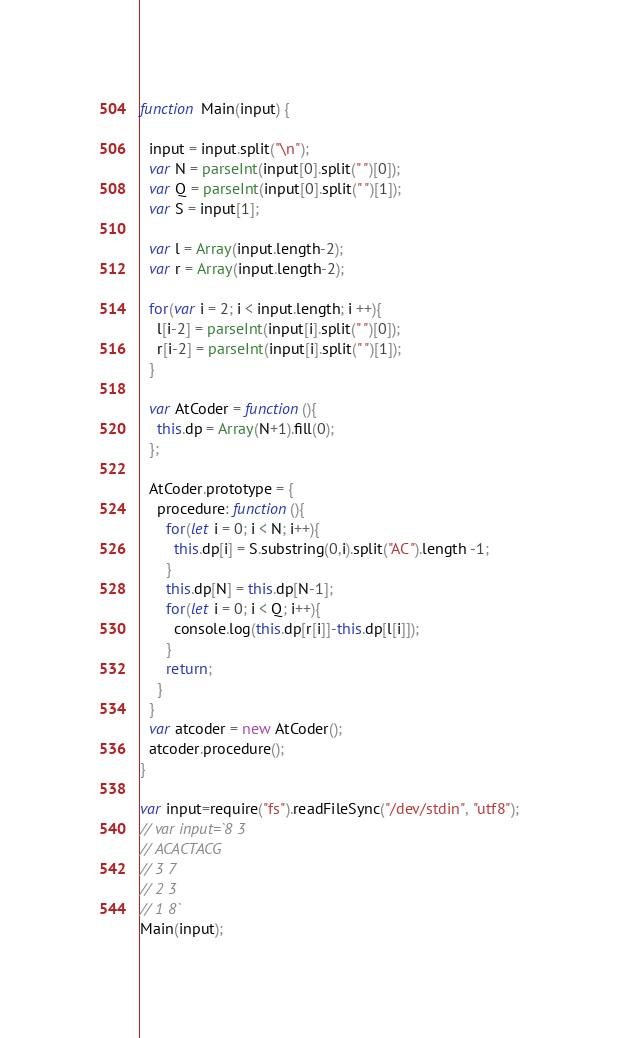<code> <loc_0><loc_0><loc_500><loc_500><_TypeScript_>function Main(input) {

  input = input.split("\n");
  var N = parseInt(input[0].split(" ")[0]);
  var Q = parseInt(input[0].split(" ")[1]);
  var S = input[1];

  var l = Array(input.length-2);
  var r = Array(input.length-2);

  for(var i = 2; i < input.length; i ++){
    l[i-2] = parseInt(input[i].split(" ")[0]);
    r[i-2] = parseInt(input[i].split(" ")[1]);
  }

  var AtCoder = function(){
    this.dp = Array(N+1).fill(0);
  };

  AtCoder.prototype = {
    procedure: function(){
      for(let i = 0; i < N; i++){
        this.dp[i] = S.substring(0,i).split("AC").length -1;
      }
      this.dp[N] = this.dp[N-1];
      for(let i = 0; i < Q; i++){
        console.log(this.dp[r[i]]-this.dp[l[i]]);
      }
      return;
    }
  }
  var atcoder = new AtCoder();
  atcoder.procedure();
}

var input=require("fs").readFileSync("/dev/stdin", "utf8");
// var input=`8 3
// ACACTACG
// 3 7
// 2 3
// 1 8`
Main(input);
</code> 